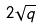<formula> <loc_0><loc_0><loc_500><loc_500>2 \sqrt { q }</formula> 